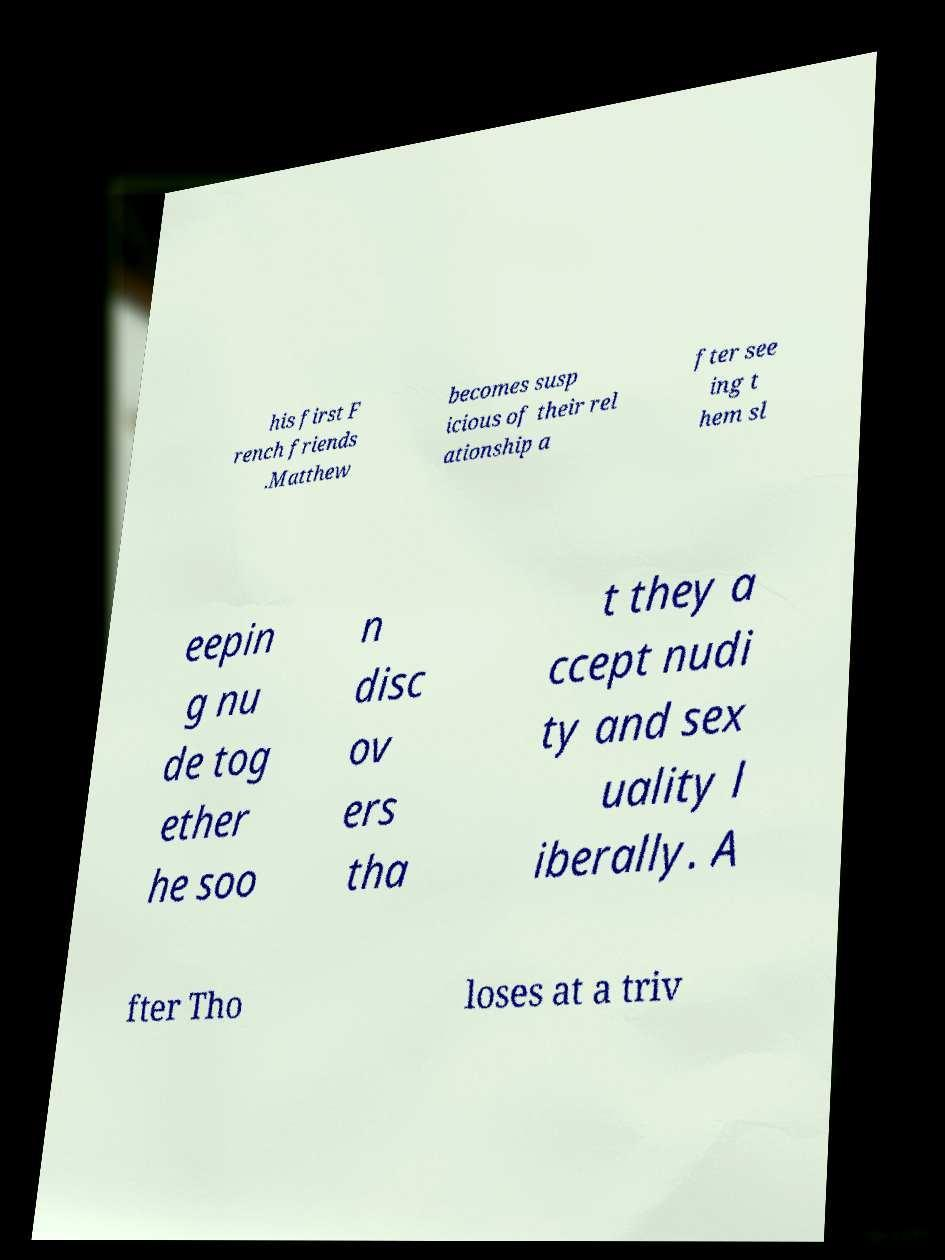Please read and relay the text visible in this image. What does it say? his first F rench friends .Matthew becomes susp icious of their rel ationship a fter see ing t hem sl eepin g nu de tog ether he soo n disc ov ers tha t they a ccept nudi ty and sex uality l iberally. A fter Tho loses at a triv 